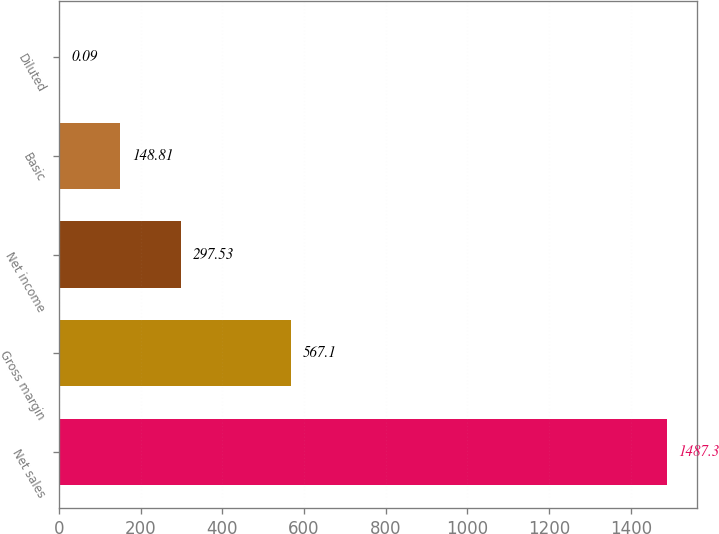Convert chart. <chart><loc_0><loc_0><loc_500><loc_500><bar_chart><fcel>Net sales<fcel>Gross margin<fcel>Net income<fcel>Basic<fcel>Diluted<nl><fcel>1487.3<fcel>567.1<fcel>297.53<fcel>148.81<fcel>0.09<nl></chart> 